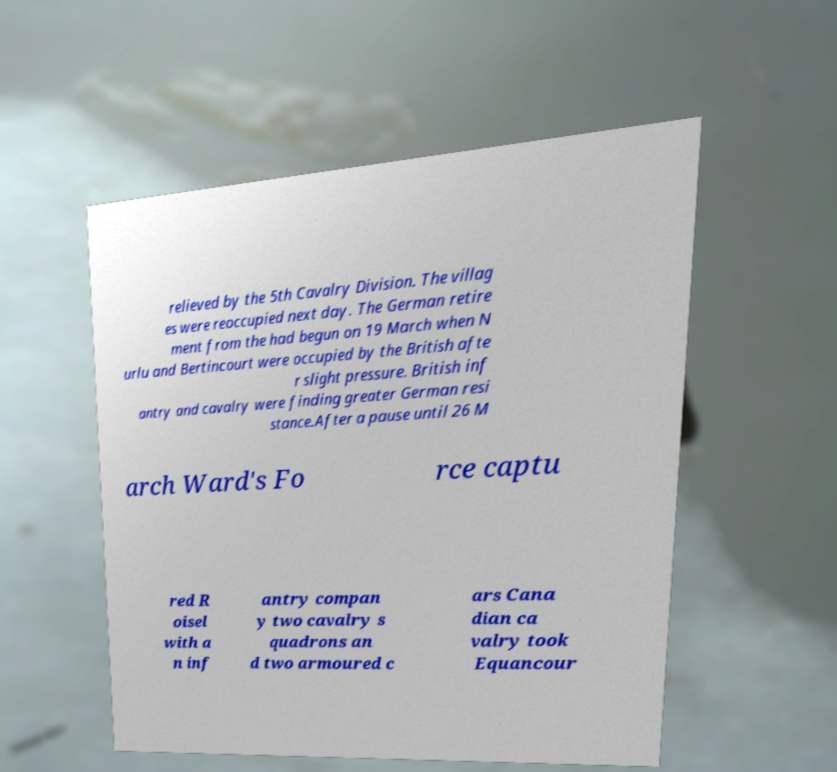Could you extract and type out the text from this image? relieved by the 5th Cavalry Division. The villag es were reoccupied next day. The German retire ment from the had begun on 19 March when N urlu and Bertincourt were occupied by the British afte r slight pressure. British inf antry and cavalry were finding greater German resi stance.After a pause until 26 M arch Ward's Fo rce captu red R oisel with a n inf antry compan y two cavalry s quadrons an d two armoured c ars Cana dian ca valry took Equancour 